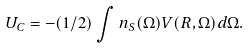<formula> <loc_0><loc_0><loc_500><loc_500>U _ { C } = - ( 1 / 2 ) \int n _ { S } ( \Omega ) V ( R , \Omega ) d \Omega .</formula> 